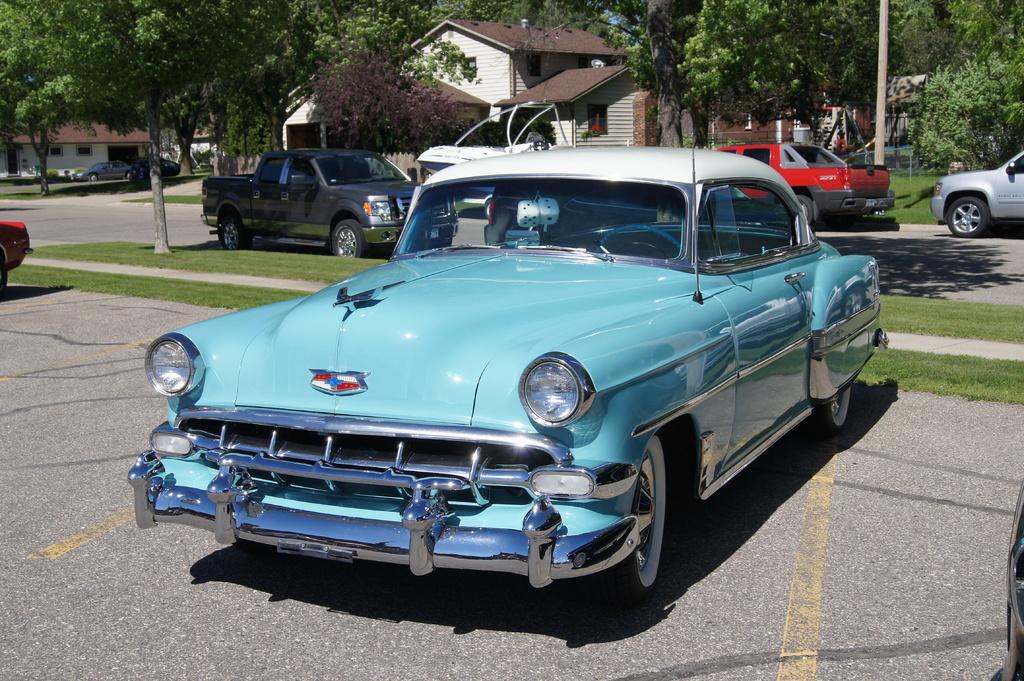How would you summarize this image in a sentence or two? In the center of the image we can see a car. In the background of the image we can see the trees, buildings, roofs, vehicles, road, grass and pole. 